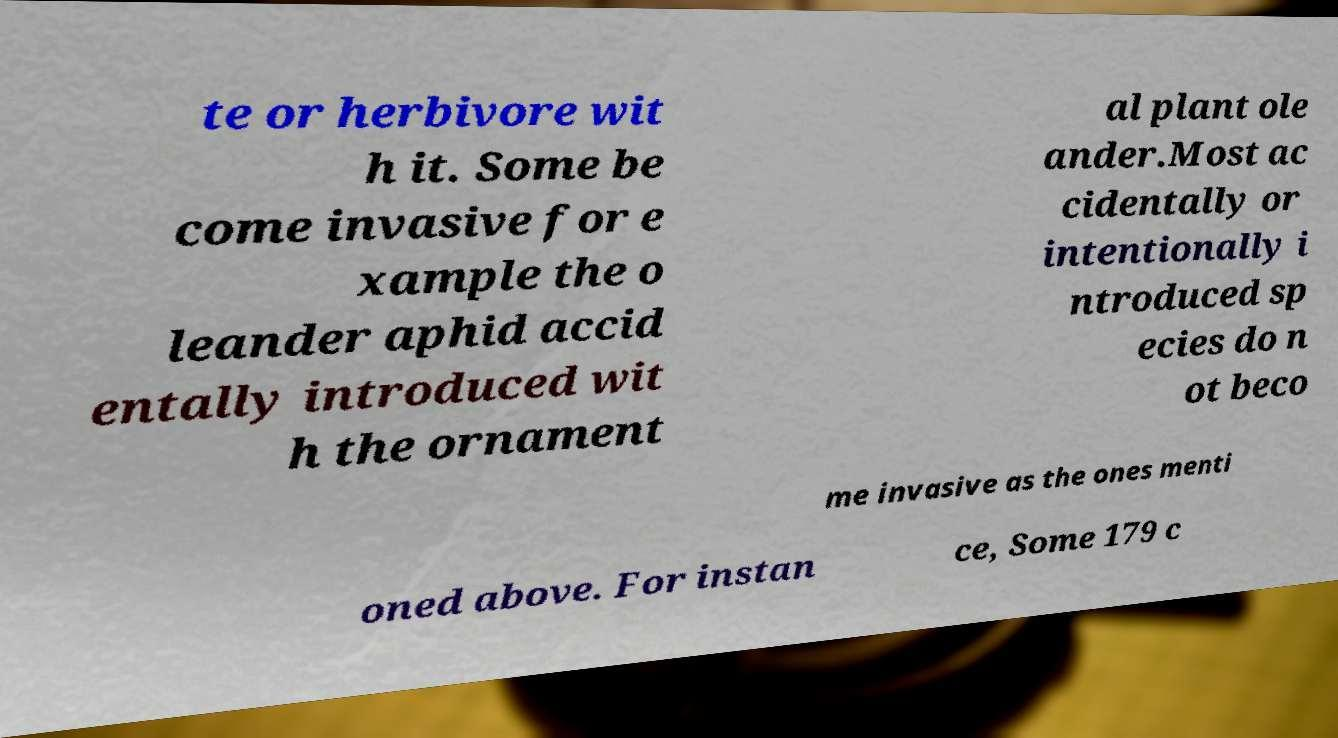For documentation purposes, I need the text within this image transcribed. Could you provide that? te or herbivore wit h it. Some be come invasive for e xample the o leander aphid accid entally introduced wit h the ornament al plant ole ander.Most ac cidentally or intentionally i ntroduced sp ecies do n ot beco me invasive as the ones menti oned above. For instan ce, Some 179 c 